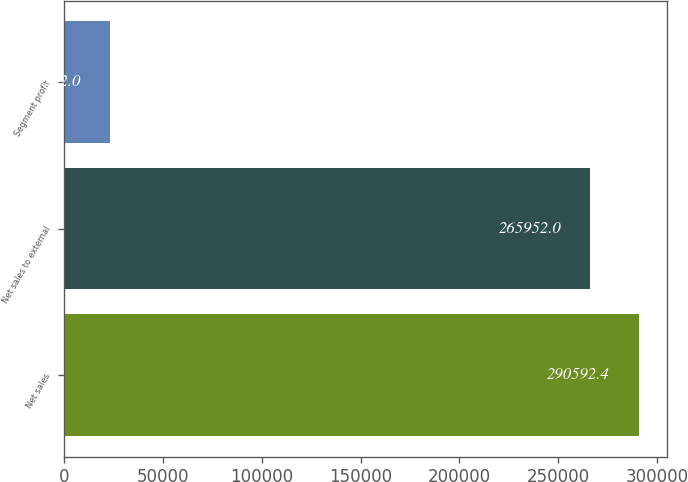Convert chart to OTSL. <chart><loc_0><loc_0><loc_500><loc_500><bar_chart><fcel>Net sales<fcel>Net sales to external<fcel>Segment profit<nl><fcel>290592<fcel>265952<fcel>23522<nl></chart> 